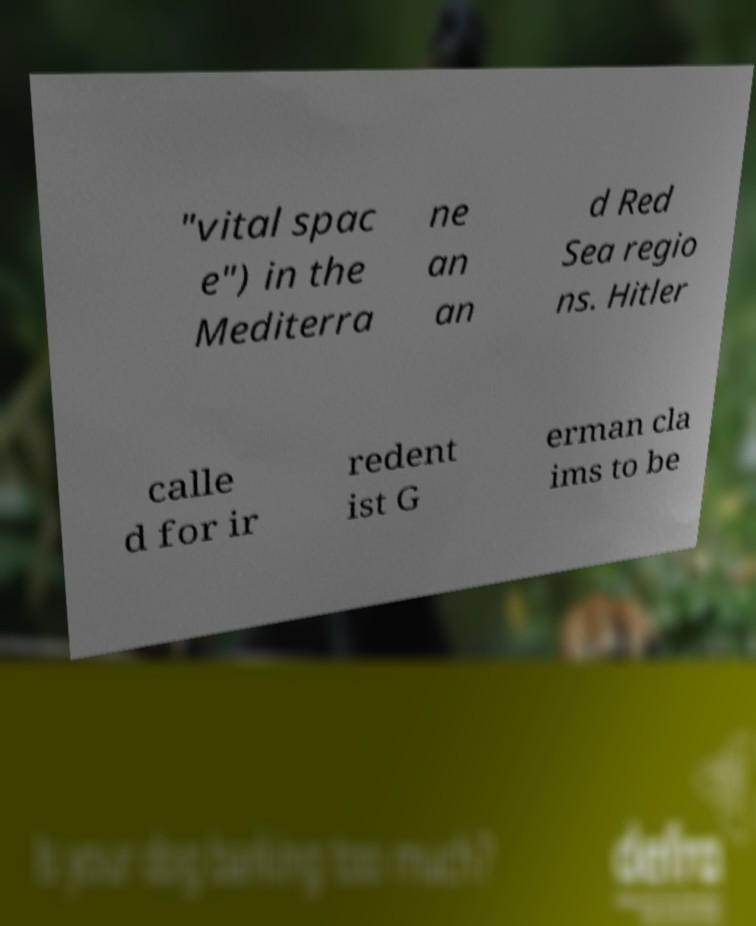For documentation purposes, I need the text within this image transcribed. Could you provide that? "vital spac e") in the Mediterra ne an an d Red Sea regio ns. Hitler calle d for ir redent ist G erman cla ims to be 